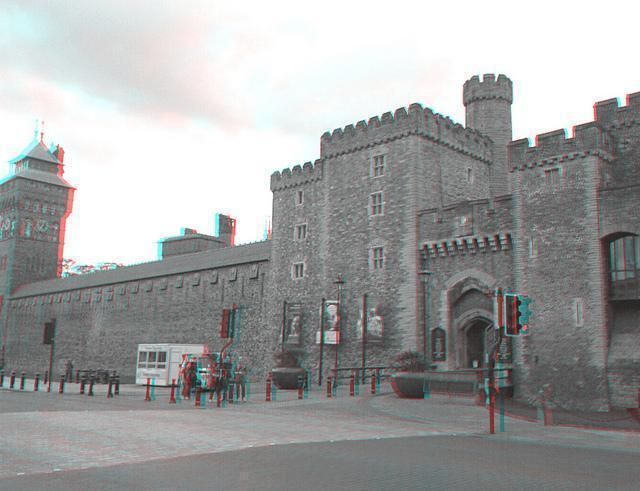What instance of building is shown in the image?
Select the accurate response from the four choices given to answer the question.
Options: Tourist spot, government building, university, castle. Tourist spot. What sort of building stand in could this building substitute for in a movie?
Indicate the correct choice and explain in the format: 'Answer: answer
Rationale: rationale.'
Options: Nunnery, castle, 711, taxi stand. Answer: castle.
Rationale: By the design and what materials was used to make this structure it's easy to get the correct answer. 